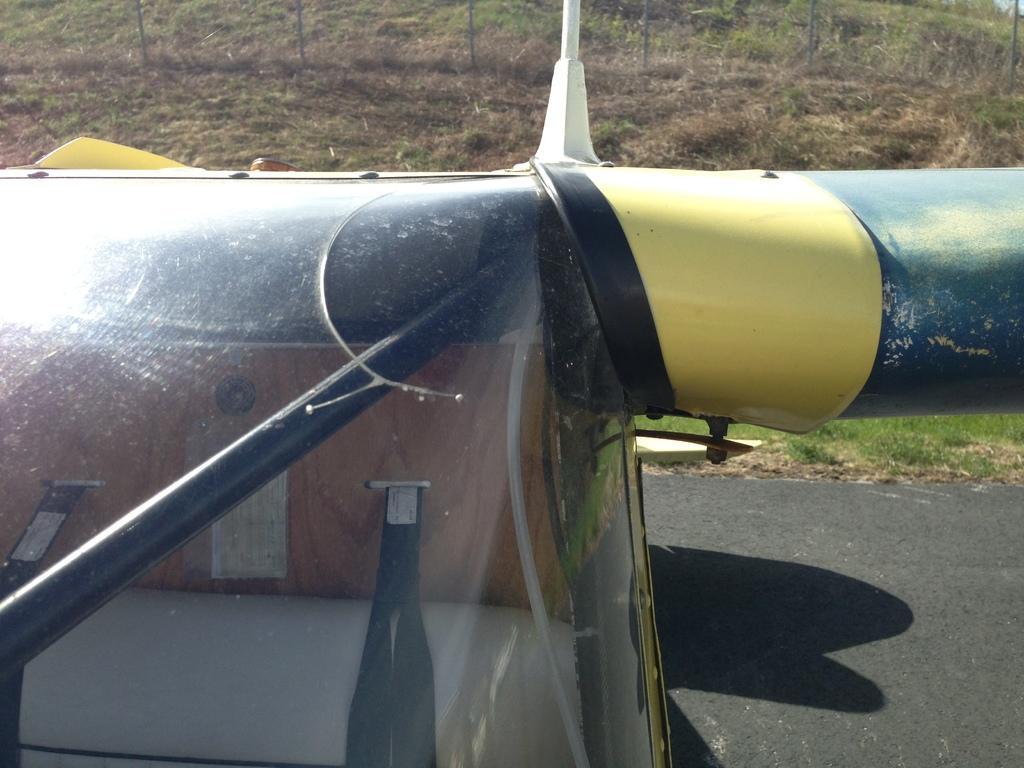In one or two sentences, can you explain what this image depicts? In this image I can see a vehicle on the road. On the top of the image I can see the ground and the grass. 